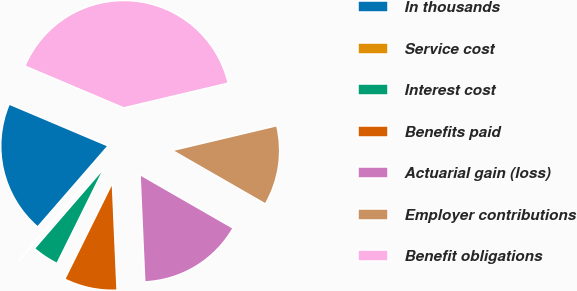Convert chart to OTSL. <chart><loc_0><loc_0><loc_500><loc_500><pie_chart><fcel>In thousands<fcel>Service cost<fcel>Interest cost<fcel>Benefits paid<fcel>Actuarial gain (loss)<fcel>Employer contributions<fcel>Benefit obligations<nl><fcel>19.99%<fcel>0.04%<fcel>4.03%<fcel>8.02%<fcel>16.0%<fcel>12.01%<fcel>39.93%<nl></chart> 